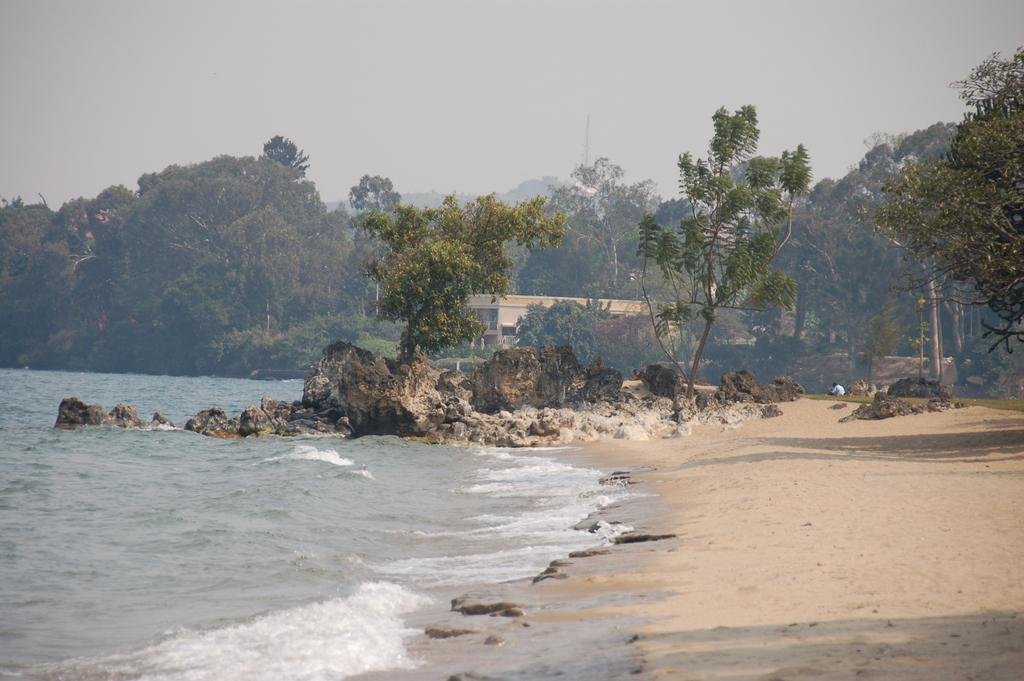What type of natural body of water is present in the image? There is an ocean in the image. What else can be seen in the sky in the image? The sky is visible in the image. What type of objects are present on the ground in the image? There are stones in the image. How many children are playing with the seed in the image? There are no children or seeds present in the image. 